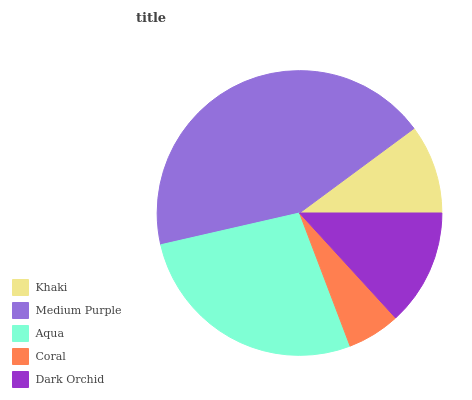Is Coral the minimum?
Answer yes or no. Yes. Is Medium Purple the maximum?
Answer yes or no. Yes. Is Aqua the minimum?
Answer yes or no. No. Is Aqua the maximum?
Answer yes or no. No. Is Medium Purple greater than Aqua?
Answer yes or no. Yes. Is Aqua less than Medium Purple?
Answer yes or no. Yes. Is Aqua greater than Medium Purple?
Answer yes or no. No. Is Medium Purple less than Aqua?
Answer yes or no. No. Is Dark Orchid the high median?
Answer yes or no. Yes. Is Dark Orchid the low median?
Answer yes or no. Yes. Is Aqua the high median?
Answer yes or no. No. Is Khaki the low median?
Answer yes or no. No. 